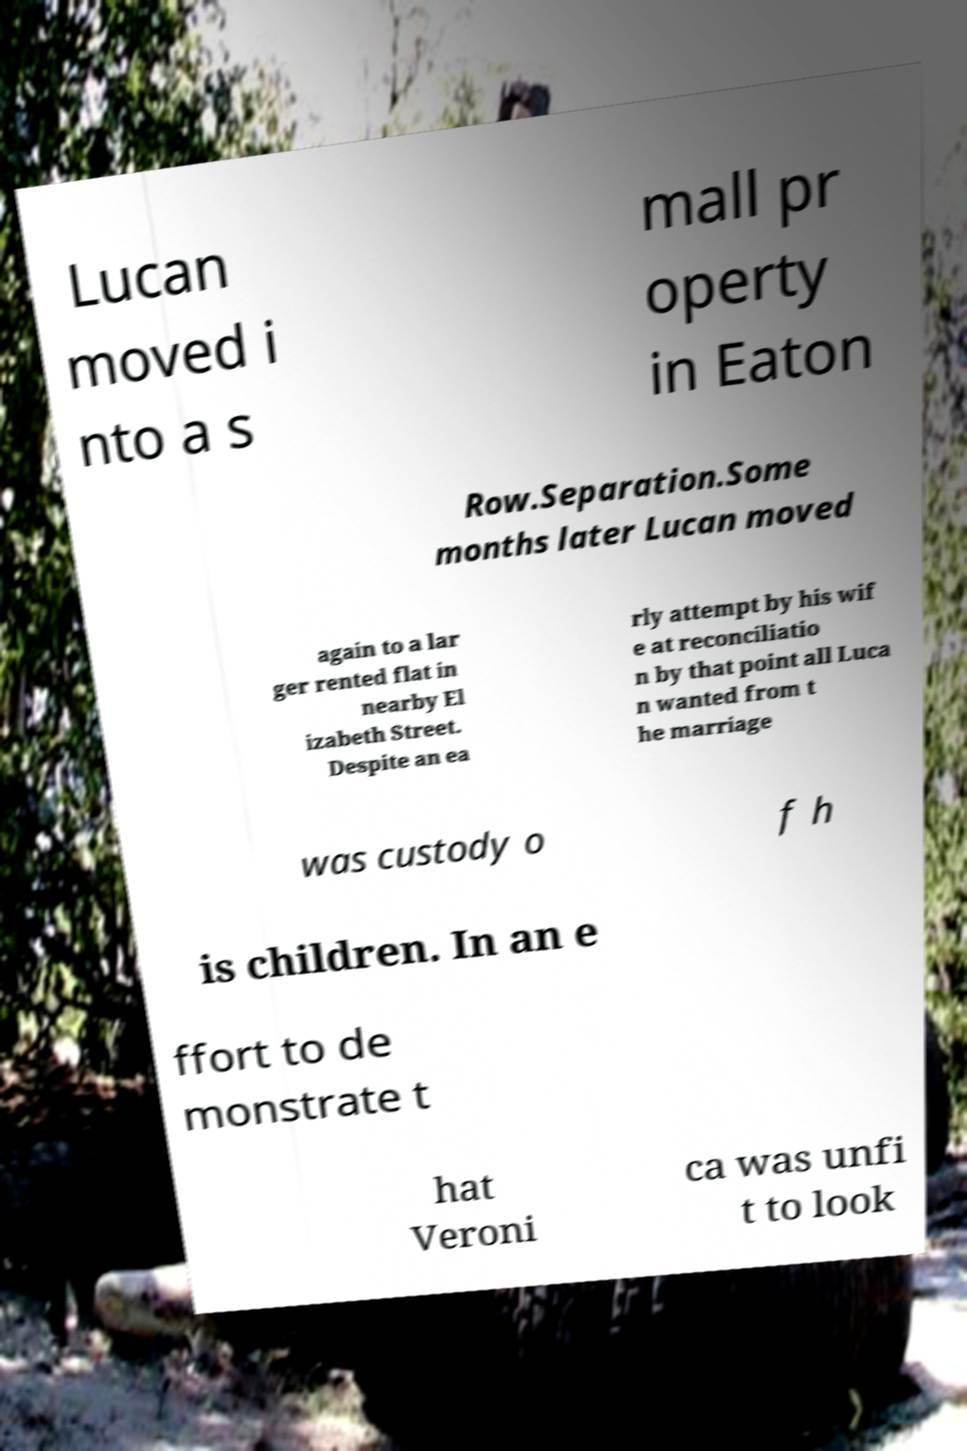There's text embedded in this image that I need extracted. Can you transcribe it verbatim? Lucan moved i nto a s mall pr operty in Eaton Row.Separation.Some months later Lucan moved again to a lar ger rented flat in nearby El izabeth Street. Despite an ea rly attempt by his wif e at reconciliatio n by that point all Luca n wanted from t he marriage was custody o f h is children. In an e ffort to de monstrate t hat Veroni ca was unfi t to look 